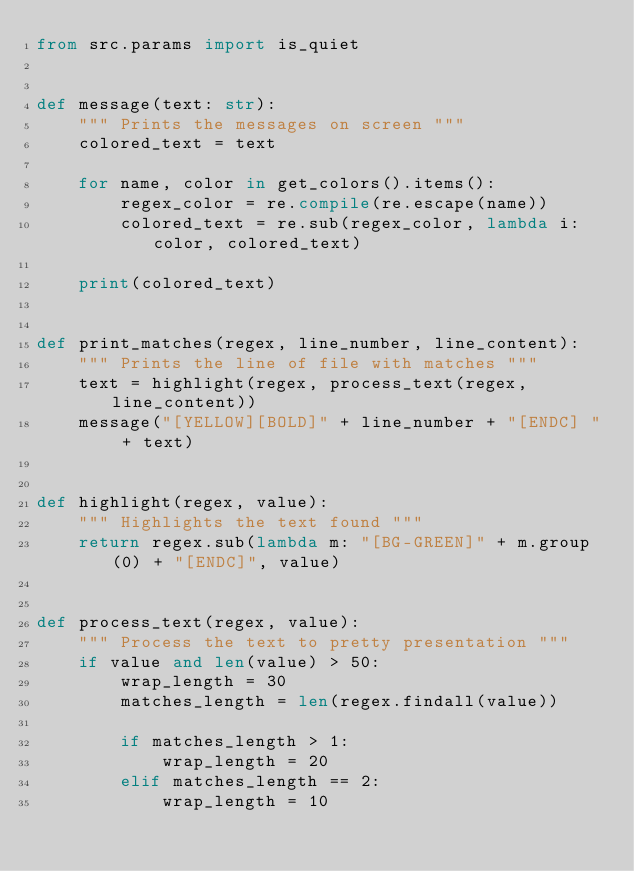Convert code to text. <code><loc_0><loc_0><loc_500><loc_500><_Python_>from src.params import is_quiet


def message(text: str):
    """ Prints the messages on screen """
    colored_text = text

    for name, color in get_colors().items():
        regex_color = re.compile(re.escape(name))
        colored_text = re.sub(regex_color, lambda i: color, colored_text)

    print(colored_text)


def print_matches(regex, line_number, line_content):
    """ Prints the line of file with matches """
    text = highlight(regex, process_text(regex, line_content))
    message("[YELLOW][BOLD]" + line_number + "[ENDC] " + text)


def highlight(regex, value):
    """ Highlights the text found """
    return regex.sub(lambda m: "[BG-GREEN]" + m.group(0) + "[ENDC]", value)


def process_text(regex, value):
    """ Process the text to pretty presentation """
    if value and len(value) > 50:
        wrap_length = 30
        matches_length = len(regex.findall(value))

        if matches_length > 1:
            wrap_length = 20
        elif matches_length == 2:
            wrap_length = 10</code> 